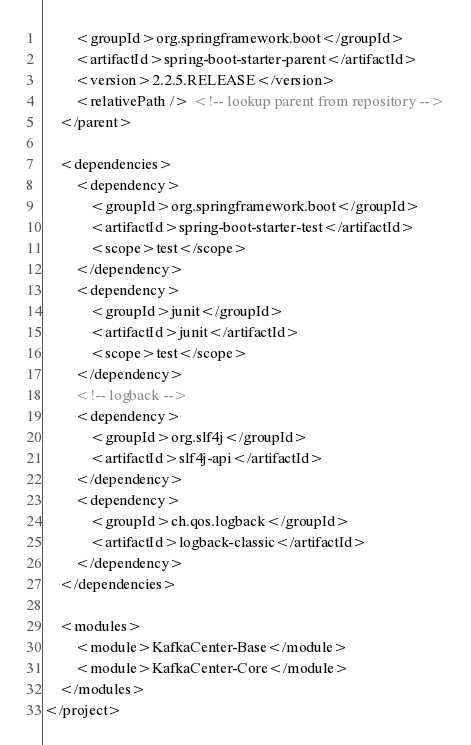Convert code to text. <code><loc_0><loc_0><loc_500><loc_500><_XML_>		<groupId>org.springframework.boot</groupId>
		<artifactId>spring-boot-starter-parent</artifactId>
		<version>2.2.5.RELEASE</version>
		<relativePath /> <!-- lookup parent from repository -->
	</parent>

	<dependencies>
		<dependency>
			<groupId>org.springframework.boot</groupId>
			<artifactId>spring-boot-starter-test</artifactId>
			<scope>test</scope>
		</dependency>
		<dependency>
			<groupId>junit</groupId>
			<artifactId>junit</artifactId>
			<scope>test</scope>
		</dependency>
		<!-- logback -->
		<dependency>
			<groupId>org.slf4j</groupId>
			<artifactId>slf4j-api</artifactId>
		</dependency>
		<dependency>
			<groupId>ch.qos.logback</groupId>
			<artifactId>logback-classic</artifactId>
		</dependency>
	</dependencies>

	<modules>
		<module>KafkaCenter-Base</module>
		<module>KafkaCenter-Core</module>
	</modules>
</project></code> 